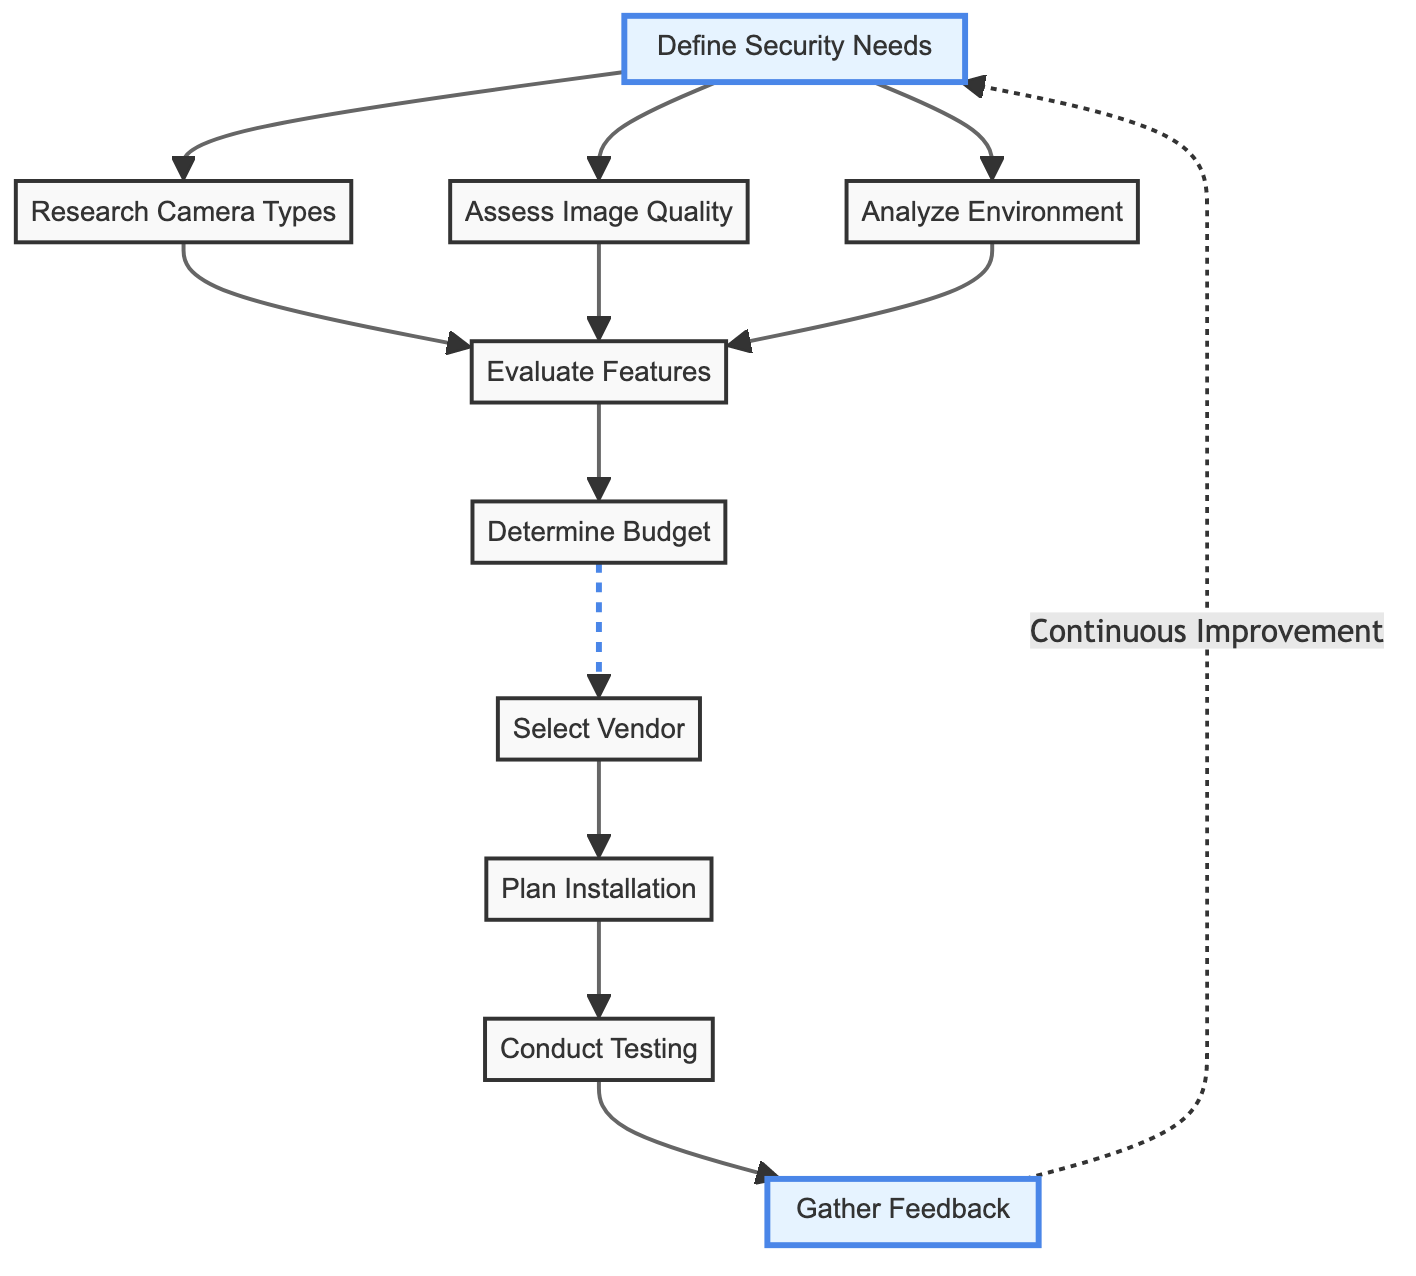What is the first step in the flow chart? The first step is "Define Security Needs," which is the starting node in the flow chart. This is the first action that must be taken to evaluate and select security cameras.
Answer: Define Security Needs How many main nodes are in the flow chart? To find out the total number of main nodes, we count each unique element in the "elements" list, which results in ten nodes.
Answer: 10 What is the connection between "Budget" and "Vendor Selection"? "Budget" is a direct predecessor to "Vendor Selection". This means that after determining the budget, the next logical step is to select a vendor based on the available budget.
Answer: Budget → Vendor Selection Which node leads to "Testing"? The node that leads to "Testing" is "Installation". Once the camera installation has been planned and executed, testing of the system follows.
Answer: Installation What action is taken after "Conduct Testing"? After "Conduct Testing," the next action is to "Gather Feedback", indicating that feedback is collected to assess the effectiveness of the system.
Answer: Gather Feedback How does "Gather Feedback" relate back to the flow? "Gather Feedback" has a dashed line indicating that it leads back to "Define Security Needs." This illustrates a loop for continuous improvement based on the feedback collected.
Answer: Continuous Improvement Which features can be evaluated according to the flow? "Evaluate Features" considers various capabilities such as motion detection, remote access, and storage options, based on previous assessments.
Answer: Features such as motion detection, remote access, and storage options What type of camera types are considered after "Defining Security Needs"? The camera types evaluated after defining security needs can include different models like dome, bullet, and PTZ cameras.
Answer: Dome, bullet, PTZ What is the last node in the flow chart? The last node in the flow chart is "Gather Feedback," which signifies the need to assess and improve the implemented security solution after all previous steps have been completed.
Answer: Gather Feedback 